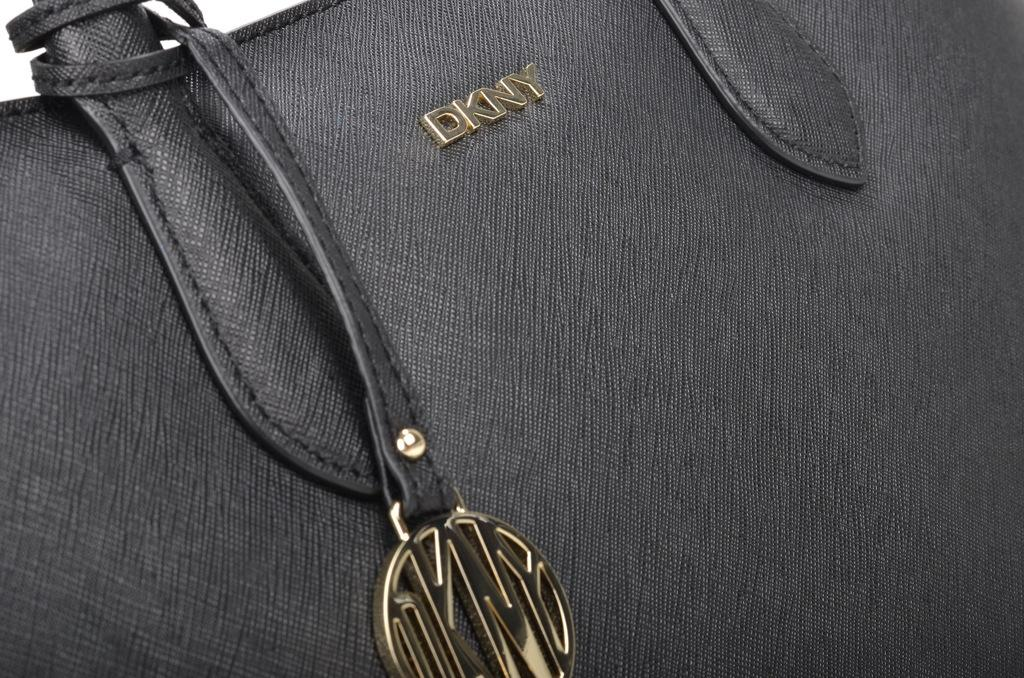What type of accessory is visible in the image? There is a black handbag in the image. Is there any text or branding on the handbag? Yes, the name 'DKNJ' is written on the handbag. How many ladybugs can be seen crawling on the handbag in the image? There are no ladybugs present on the handbag in the image. Can you describe the kicking motion of the frogs in the image? There are no frogs present in the image, so there is no kicking motion to describe. 